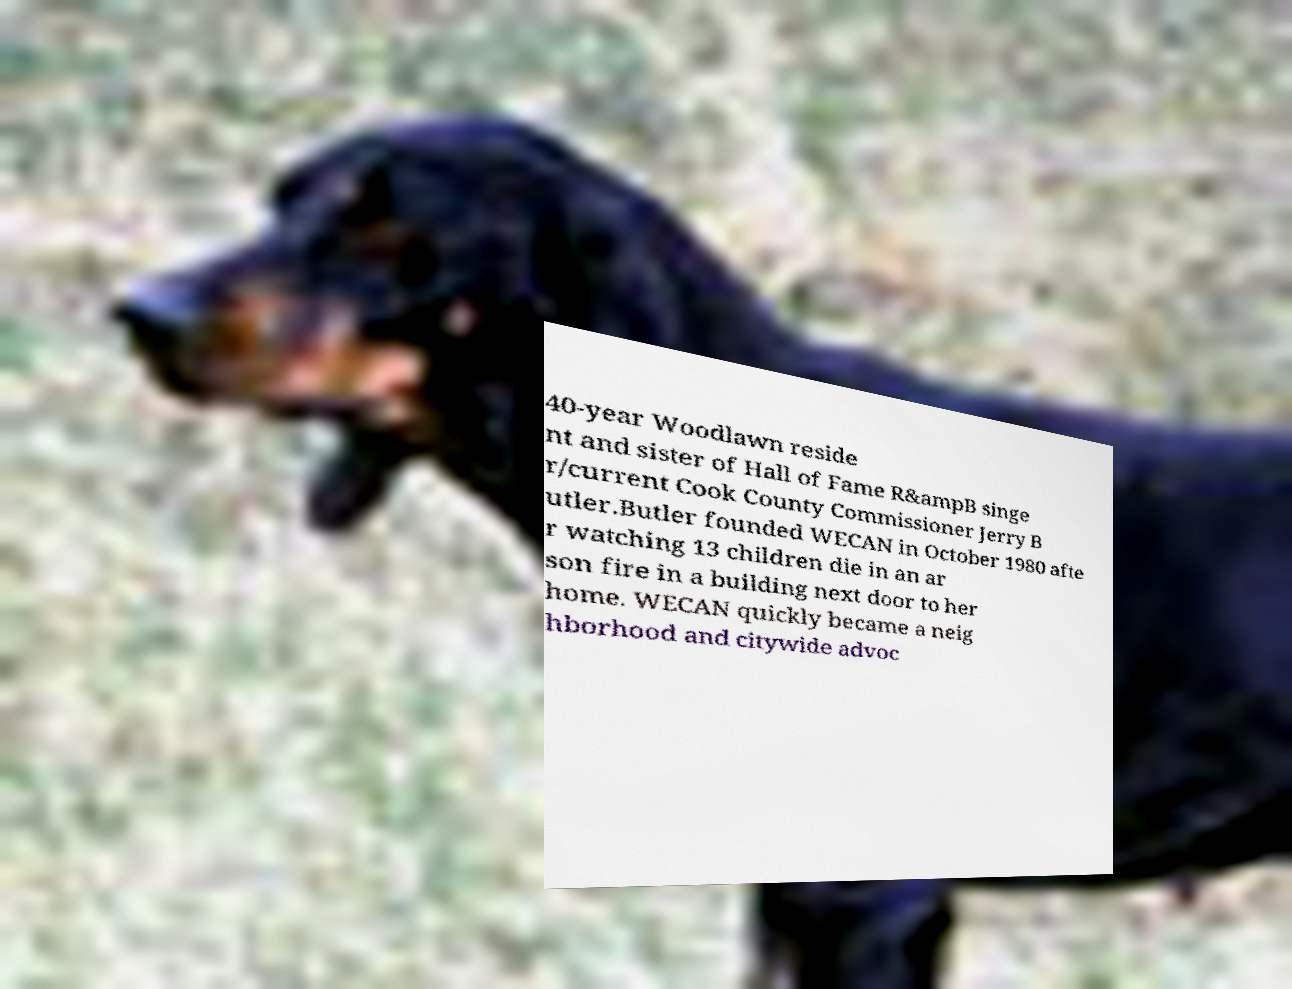There's text embedded in this image that I need extracted. Can you transcribe it verbatim? 40-year Woodlawn reside nt and sister of Hall of Fame R&ampB singe r/current Cook County Commissioner Jerry B utler.Butler founded WECAN in October 1980 afte r watching 13 children die in an ar son fire in a building next door to her home. WECAN quickly became a neig hborhood and citywide advoc 